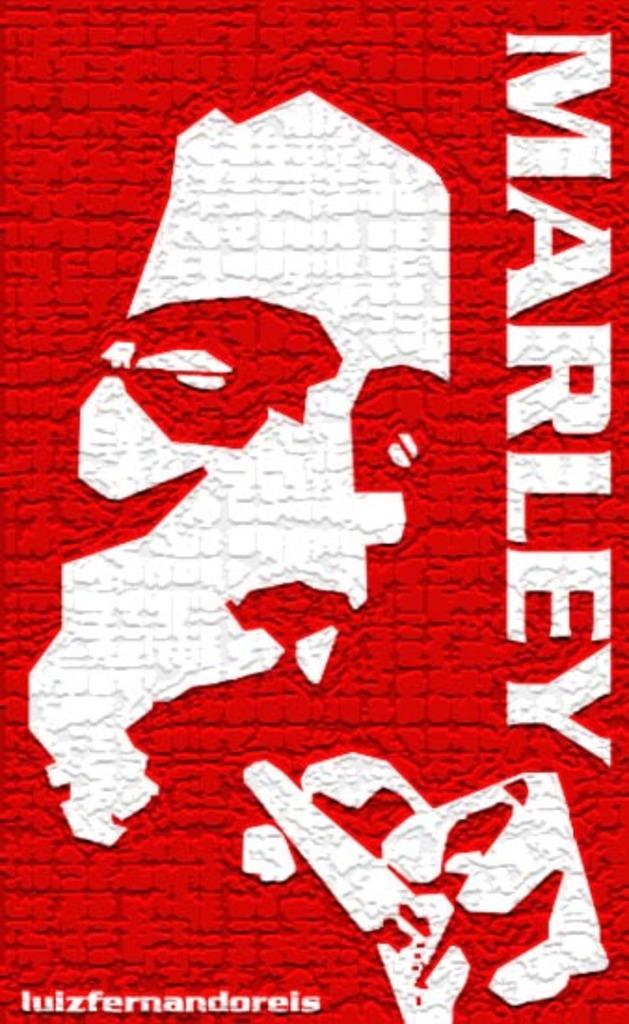<image>
Relay a brief, clear account of the picture shown. A red and white sign promoting Bob Marley. 